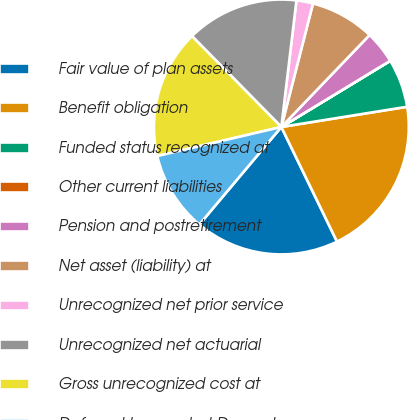Convert chart to OTSL. <chart><loc_0><loc_0><loc_500><loc_500><pie_chart><fcel>Fair value of plan assets<fcel>Benefit obligation<fcel>Funded status recognized at<fcel>Other current liabilities<fcel>Pension and postretirement<fcel>Net asset (liability) at<fcel>Unrecognized net prior service<fcel>Unrecognized net actuarial<fcel>Gross unrecognized cost at<fcel>Deferred tax asset at December<nl><fcel>18.32%<fcel>20.34%<fcel>6.15%<fcel>0.01%<fcel>4.13%<fcel>8.18%<fcel>2.1%<fcel>14.26%<fcel>16.29%<fcel>10.21%<nl></chart> 